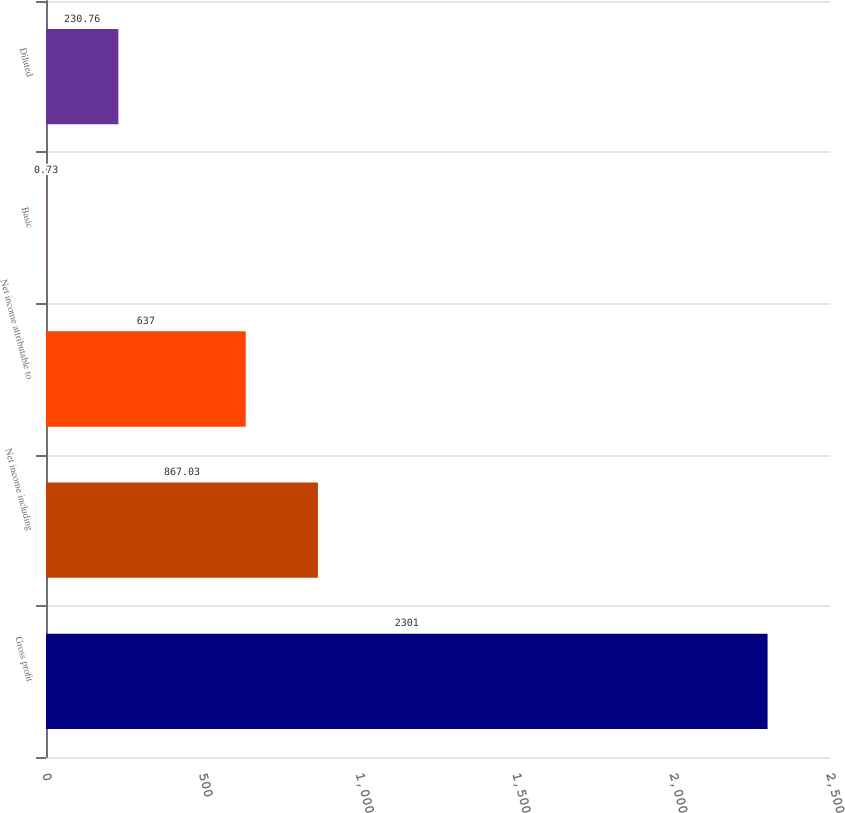Convert chart to OTSL. <chart><loc_0><loc_0><loc_500><loc_500><bar_chart><fcel>Gross profit<fcel>Net income including<fcel>Net income attributable to<fcel>Basic<fcel>Diluted<nl><fcel>2301<fcel>867.03<fcel>637<fcel>0.73<fcel>230.76<nl></chart> 